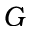Convert formula to latex. <formula><loc_0><loc_0><loc_500><loc_500>G</formula> 